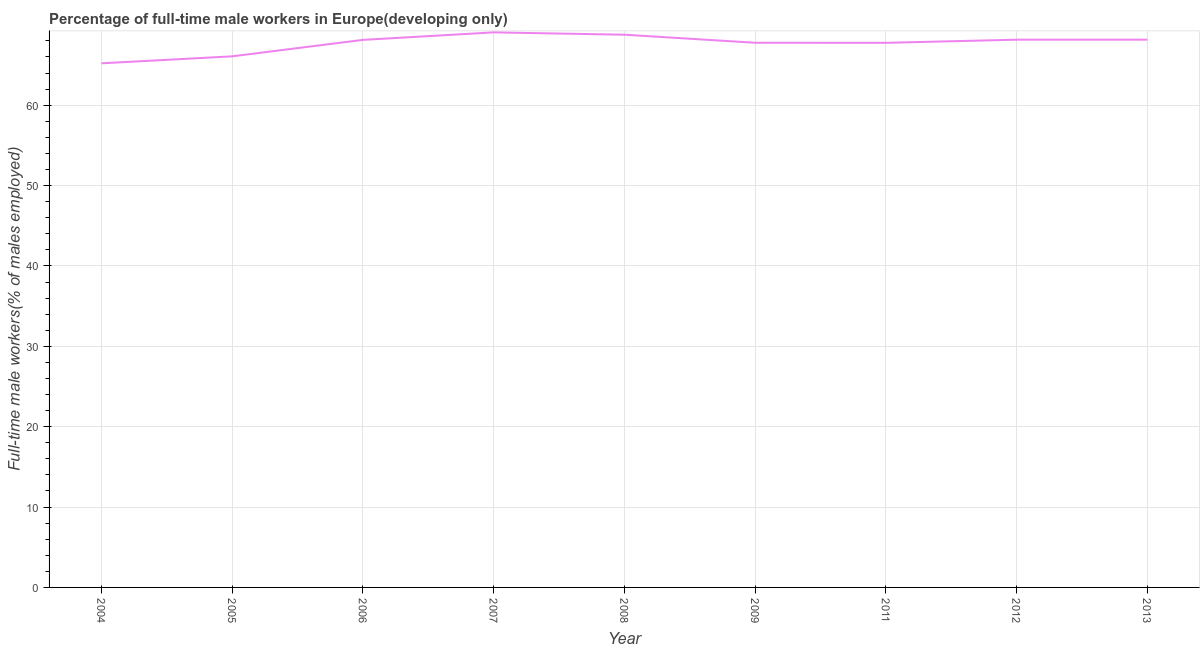What is the percentage of full-time male workers in 2012?
Your response must be concise. 68.15. Across all years, what is the maximum percentage of full-time male workers?
Offer a very short reply. 69.06. Across all years, what is the minimum percentage of full-time male workers?
Make the answer very short. 65.21. In which year was the percentage of full-time male workers minimum?
Provide a short and direct response. 2004. What is the sum of the percentage of full-time male workers?
Make the answer very short. 609.06. What is the difference between the percentage of full-time male workers in 2011 and 2013?
Provide a short and direct response. -0.39. What is the average percentage of full-time male workers per year?
Make the answer very short. 67.67. What is the median percentage of full-time male workers?
Keep it short and to the point. 68.12. In how many years, is the percentage of full-time male workers greater than 46 %?
Keep it short and to the point. 9. What is the ratio of the percentage of full-time male workers in 2004 to that in 2013?
Provide a succinct answer. 0.96. What is the difference between the highest and the second highest percentage of full-time male workers?
Make the answer very short. 0.29. Is the sum of the percentage of full-time male workers in 2009 and 2011 greater than the maximum percentage of full-time male workers across all years?
Your answer should be very brief. Yes. What is the difference between the highest and the lowest percentage of full-time male workers?
Your answer should be compact. 3.85. In how many years, is the percentage of full-time male workers greater than the average percentage of full-time male workers taken over all years?
Your response must be concise. 7. How many lines are there?
Make the answer very short. 1. What is the difference between two consecutive major ticks on the Y-axis?
Provide a short and direct response. 10. Are the values on the major ticks of Y-axis written in scientific E-notation?
Your response must be concise. No. Does the graph contain any zero values?
Your answer should be compact. No. What is the title of the graph?
Provide a short and direct response. Percentage of full-time male workers in Europe(developing only). What is the label or title of the X-axis?
Your answer should be very brief. Year. What is the label or title of the Y-axis?
Your answer should be very brief. Full-time male workers(% of males employed). What is the Full-time male workers(% of males employed) of 2004?
Keep it short and to the point. 65.21. What is the Full-time male workers(% of males employed) in 2005?
Offer a very short reply. 66.08. What is the Full-time male workers(% of males employed) in 2006?
Your answer should be very brief. 68.12. What is the Full-time male workers(% of males employed) of 2007?
Your answer should be very brief. 69.06. What is the Full-time male workers(% of males employed) in 2008?
Ensure brevity in your answer.  68.77. What is the Full-time male workers(% of males employed) in 2009?
Provide a short and direct response. 67.77. What is the Full-time male workers(% of males employed) in 2011?
Give a very brief answer. 67.76. What is the Full-time male workers(% of males employed) in 2012?
Keep it short and to the point. 68.15. What is the Full-time male workers(% of males employed) of 2013?
Your answer should be very brief. 68.15. What is the difference between the Full-time male workers(% of males employed) in 2004 and 2005?
Provide a short and direct response. -0.87. What is the difference between the Full-time male workers(% of males employed) in 2004 and 2006?
Offer a terse response. -2.92. What is the difference between the Full-time male workers(% of males employed) in 2004 and 2007?
Ensure brevity in your answer.  -3.85. What is the difference between the Full-time male workers(% of males employed) in 2004 and 2008?
Your answer should be compact. -3.56. What is the difference between the Full-time male workers(% of males employed) in 2004 and 2009?
Provide a succinct answer. -2.56. What is the difference between the Full-time male workers(% of males employed) in 2004 and 2011?
Give a very brief answer. -2.55. What is the difference between the Full-time male workers(% of males employed) in 2004 and 2012?
Your response must be concise. -2.94. What is the difference between the Full-time male workers(% of males employed) in 2004 and 2013?
Make the answer very short. -2.94. What is the difference between the Full-time male workers(% of males employed) in 2005 and 2006?
Give a very brief answer. -2.05. What is the difference between the Full-time male workers(% of males employed) in 2005 and 2007?
Offer a terse response. -2.98. What is the difference between the Full-time male workers(% of males employed) in 2005 and 2008?
Provide a succinct answer. -2.69. What is the difference between the Full-time male workers(% of males employed) in 2005 and 2009?
Ensure brevity in your answer.  -1.69. What is the difference between the Full-time male workers(% of males employed) in 2005 and 2011?
Ensure brevity in your answer.  -1.68. What is the difference between the Full-time male workers(% of males employed) in 2005 and 2012?
Offer a terse response. -2.07. What is the difference between the Full-time male workers(% of males employed) in 2005 and 2013?
Your answer should be very brief. -2.07. What is the difference between the Full-time male workers(% of males employed) in 2006 and 2007?
Offer a terse response. -0.93. What is the difference between the Full-time male workers(% of males employed) in 2006 and 2008?
Provide a short and direct response. -0.64. What is the difference between the Full-time male workers(% of males employed) in 2006 and 2009?
Your response must be concise. 0.36. What is the difference between the Full-time male workers(% of males employed) in 2006 and 2011?
Your answer should be compact. 0.37. What is the difference between the Full-time male workers(% of males employed) in 2006 and 2012?
Offer a terse response. -0.02. What is the difference between the Full-time male workers(% of males employed) in 2006 and 2013?
Keep it short and to the point. -0.03. What is the difference between the Full-time male workers(% of males employed) in 2007 and 2008?
Offer a very short reply. 0.29. What is the difference between the Full-time male workers(% of males employed) in 2007 and 2009?
Give a very brief answer. 1.29. What is the difference between the Full-time male workers(% of males employed) in 2007 and 2011?
Give a very brief answer. 1.3. What is the difference between the Full-time male workers(% of males employed) in 2007 and 2012?
Your answer should be very brief. 0.91. What is the difference between the Full-time male workers(% of males employed) in 2007 and 2013?
Provide a short and direct response. 0.91. What is the difference between the Full-time male workers(% of males employed) in 2008 and 2009?
Provide a short and direct response. 1. What is the difference between the Full-time male workers(% of males employed) in 2008 and 2011?
Give a very brief answer. 1.01. What is the difference between the Full-time male workers(% of males employed) in 2008 and 2012?
Give a very brief answer. 0.62. What is the difference between the Full-time male workers(% of males employed) in 2008 and 2013?
Offer a terse response. 0.62. What is the difference between the Full-time male workers(% of males employed) in 2009 and 2011?
Provide a short and direct response. 0.01. What is the difference between the Full-time male workers(% of males employed) in 2009 and 2012?
Your answer should be compact. -0.38. What is the difference between the Full-time male workers(% of males employed) in 2009 and 2013?
Offer a terse response. -0.38. What is the difference between the Full-time male workers(% of males employed) in 2011 and 2012?
Offer a very short reply. -0.39. What is the difference between the Full-time male workers(% of males employed) in 2011 and 2013?
Offer a terse response. -0.39. What is the difference between the Full-time male workers(% of males employed) in 2012 and 2013?
Your answer should be compact. -0. What is the ratio of the Full-time male workers(% of males employed) in 2004 to that in 2005?
Your answer should be very brief. 0.99. What is the ratio of the Full-time male workers(% of males employed) in 2004 to that in 2006?
Ensure brevity in your answer.  0.96. What is the ratio of the Full-time male workers(% of males employed) in 2004 to that in 2007?
Make the answer very short. 0.94. What is the ratio of the Full-time male workers(% of males employed) in 2004 to that in 2008?
Make the answer very short. 0.95. What is the ratio of the Full-time male workers(% of males employed) in 2004 to that in 2011?
Your answer should be very brief. 0.96. What is the ratio of the Full-time male workers(% of males employed) in 2004 to that in 2012?
Your answer should be very brief. 0.96. What is the ratio of the Full-time male workers(% of males employed) in 2005 to that in 2007?
Provide a short and direct response. 0.96. What is the ratio of the Full-time male workers(% of males employed) in 2005 to that in 2008?
Offer a terse response. 0.96. What is the ratio of the Full-time male workers(% of males employed) in 2005 to that in 2011?
Provide a short and direct response. 0.97. What is the ratio of the Full-time male workers(% of males employed) in 2005 to that in 2012?
Provide a succinct answer. 0.97. What is the ratio of the Full-time male workers(% of males employed) in 2005 to that in 2013?
Keep it short and to the point. 0.97. What is the ratio of the Full-time male workers(% of males employed) in 2006 to that in 2008?
Make the answer very short. 0.99. What is the ratio of the Full-time male workers(% of males employed) in 2006 to that in 2009?
Give a very brief answer. 1. What is the ratio of the Full-time male workers(% of males employed) in 2006 to that in 2011?
Ensure brevity in your answer.  1. What is the ratio of the Full-time male workers(% of males employed) in 2006 to that in 2012?
Offer a terse response. 1. What is the ratio of the Full-time male workers(% of males employed) in 2006 to that in 2013?
Give a very brief answer. 1. What is the ratio of the Full-time male workers(% of males employed) in 2007 to that in 2008?
Keep it short and to the point. 1. What is the ratio of the Full-time male workers(% of males employed) in 2007 to that in 2011?
Your answer should be very brief. 1.02. What is the ratio of the Full-time male workers(% of males employed) in 2007 to that in 2013?
Keep it short and to the point. 1.01. What is the ratio of the Full-time male workers(% of males employed) in 2008 to that in 2009?
Offer a very short reply. 1.01. What is the ratio of the Full-time male workers(% of males employed) in 2008 to that in 2011?
Provide a succinct answer. 1.01. What is the ratio of the Full-time male workers(% of males employed) in 2008 to that in 2013?
Make the answer very short. 1.01. What is the ratio of the Full-time male workers(% of males employed) in 2009 to that in 2011?
Give a very brief answer. 1. What is the ratio of the Full-time male workers(% of males employed) in 2009 to that in 2012?
Give a very brief answer. 0.99. What is the ratio of the Full-time male workers(% of males employed) in 2011 to that in 2012?
Your response must be concise. 0.99. What is the ratio of the Full-time male workers(% of males employed) in 2011 to that in 2013?
Ensure brevity in your answer.  0.99. What is the ratio of the Full-time male workers(% of males employed) in 2012 to that in 2013?
Provide a short and direct response. 1. 